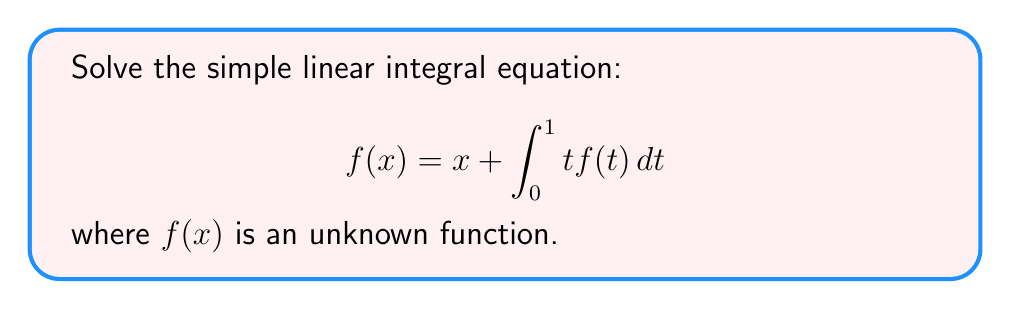Can you answer this question? Let's solve this step-by-step:

1) First, we notice that the integral doesn't depend on $x$. This means it's a constant. Let's call this constant $c$:

   $$c = \int_0^1 t f(t) dt$$

2) Now our equation becomes:

   $$f(x) = x + c$$

3) To find $c$, we can substitute this form of $f(x)$ back into the original equation:

   $$x + c = x + \int_0^1 t (t + c) dt$$

4) Let's solve the right-hand side integral:

   $$\int_0^1 t (t + c) dt = \int_0^1 (t^2 + ct) dt = [\frac{1}{3}t^3 + \frac{1}{2}ct^2]_0^1 = \frac{1}{3} + \frac{1}{2}c$$

5) Now our equation is:

   $$x + c = x + \frac{1}{3} + \frac{1}{2}c$$

6) The $x$ terms cancel out:

   $$c = \frac{1}{3} + \frac{1}{2}c$$

7) Solve for $c$:

   $$\frac{1}{2}c = \frac{1}{3}$$
   $$c = \frac{2}{3}$$

8) Therefore, the solution is:

   $$f(x) = x + \frac{2}{3}$$
Answer: $f(x) = x + \frac{2}{3}$ 